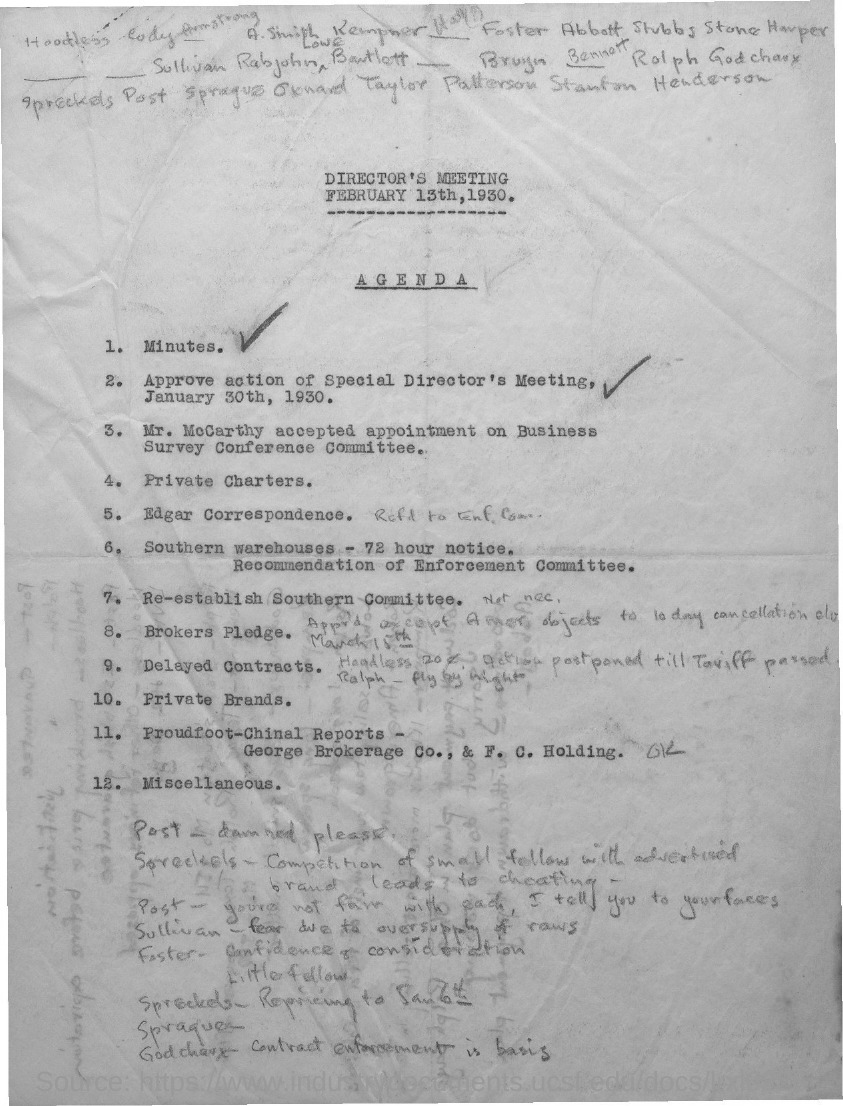When is the director's meeting held as per the agenda?
Offer a terse response. FEBRUARY 13TH, 1930. 